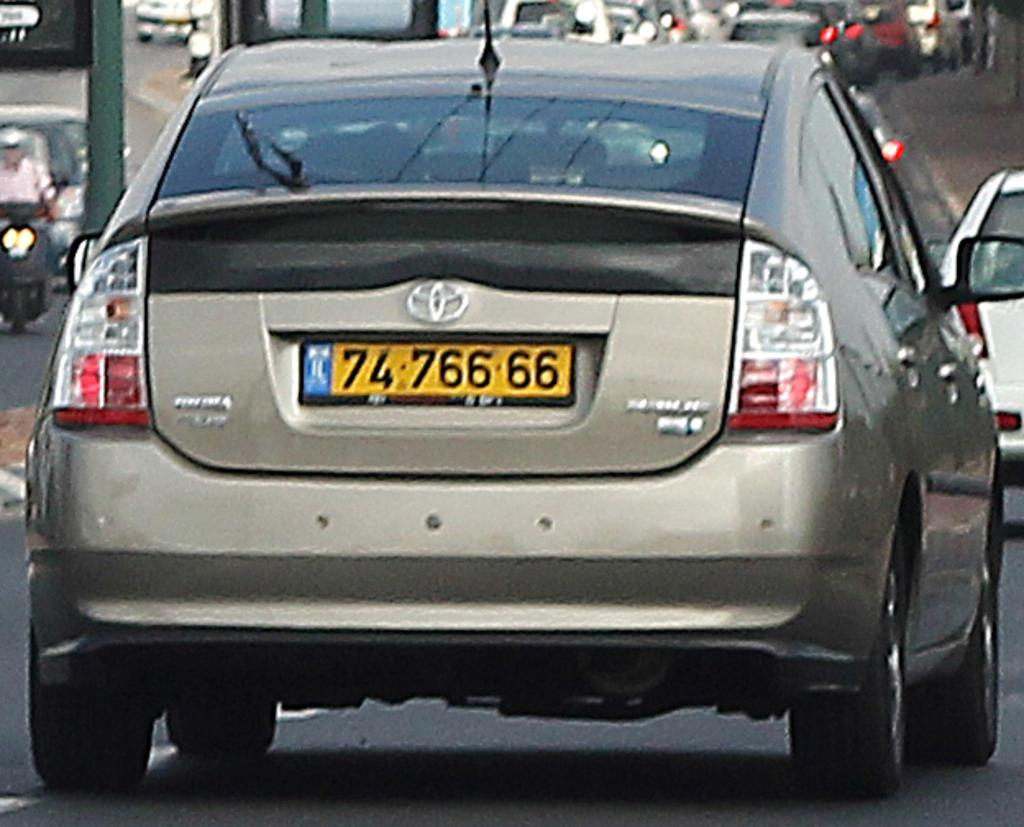What can be seen on the road in the image? There are vehicles on the road in the image. What type of comb is being used to trim the tree branches in the image? There is no comb or tree branches present in the image; it only features vehicles on the road. 